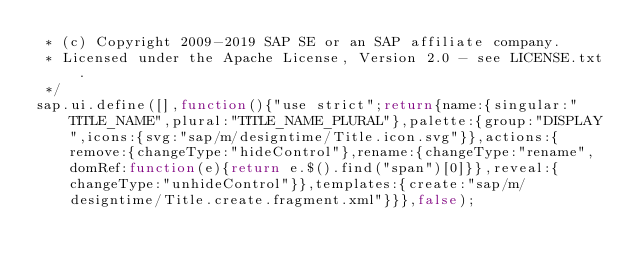Convert code to text. <code><loc_0><loc_0><loc_500><loc_500><_JavaScript_> * (c) Copyright 2009-2019 SAP SE or an SAP affiliate company.
 * Licensed under the Apache License, Version 2.0 - see LICENSE.txt.
 */
sap.ui.define([],function(){"use strict";return{name:{singular:"TITLE_NAME",plural:"TITLE_NAME_PLURAL"},palette:{group:"DISPLAY",icons:{svg:"sap/m/designtime/Title.icon.svg"}},actions:{remove:{changeType:"hideControl"},rename:{changeType:"rename",domRef:function(e){return e.$().find("span")[0]}},reveal:{changeType:"unhideControl"}},templates:{create:"sap/m/designtime/Title.create.fragment.xml"}}},false);</code> 